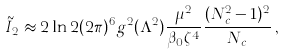<formula> <loc_0><loc_0><loc_500><loc_500>\tilde { I } _ { 2 } \approx 2 \ln 2 ( 2 \pi ) ^ { 6 } g ^ { 2 } ( \Lambda ^ { 2 } ) \frac { \mu ^ { 2 } } { \beta _ { 0 } \zeta ^ { 4 } } \frac { ( N _ { c } ^ { 2 } - 1 ) ^ { 2 } } { N _ { c } } \, ,</formula> 